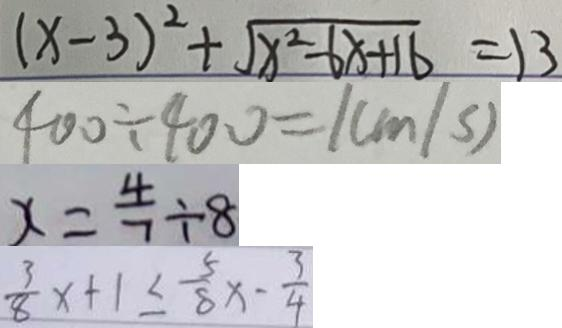Convert formula to latex. <formula><loc_0><loc_0><loc_500><loc_500>( x - 3 ) ^ { 2 } + \sqrt { x ^ { 2 } - 6 x + 1 6 } = 1 3 
 4 0 0 \div 4 0 0 = 1 ( m / s ) 
 x = \frac { 4 } { 7 } \div 8 
 \frac { 3 } { 8 } x + 1 \leq \frac { 5 } { 8 } x - \frac { 3 } { 4 }</formula> 